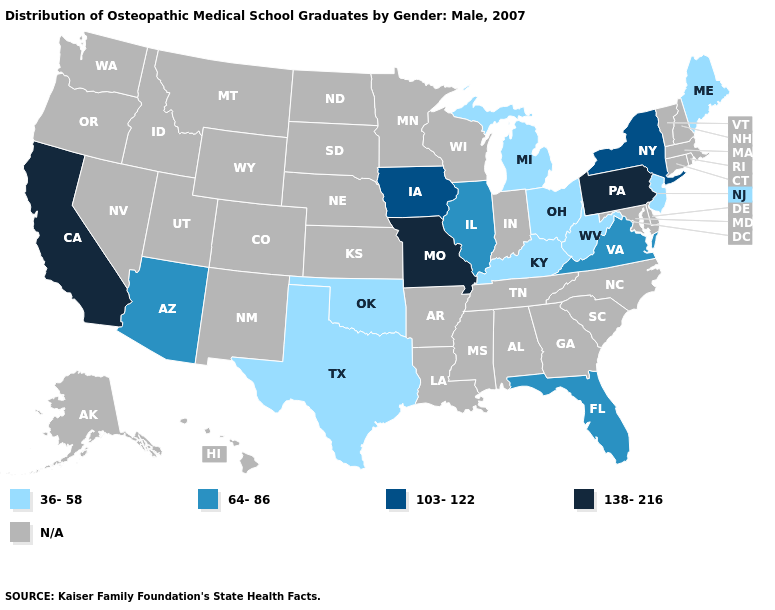Which states have the highest value in the USA?
Concise answer only. California, Missouri, Pennsylvania. Which states have the lowest value in the South?
Keep it brief. Kentucky, Oklahoma, Texas, West Virginia. Name the states that have a value in the range N/A?
Be succinct. Alabama, Alaska, Arkansas, Colorado, Connecticut, Delaware, Georgia, Hawaii, Idaho, Indiana, Kansas, Louisiana, Maryland, Massachusetts, Minnesota, Mississippi, Montana, Nebraska, Nevada, New Hampshire, New Mexico, North Carolina, North Dakota, Oregon, Rhode Island, South Carolina, South Dakota, Tennessee, Utah, Vermont, Washington, Wisconsin, Wyoming. Which states have the lowest value in the USA?
Concise answer only. Kentucky, Maine, Michigan, New Jersey, Ohio, Oklahoma, Texas, West Virginia. Among the states that border Texas , which have the highest value?
Concise answer only. Oklahoma. What is the value of New Jersey?
Quick response, please. 36-58. What is the value of Iowa?
Short answer required. 103-122. Does the map have missing data?
Give a very brief answer. Yes. Does Ohio have the lowest value in the USA?
Give a very brief answer. Yes. What is the value of Delaware?
Concise answer only. N/A. What is the value of West Virginia?
Keep it brief. 36-58. Does California have the lowest value in the West?
Short answer required. No. How many symbols are there in the legend?
Short answer required. 5. What is the highest value in the USA?
Answer briefly. 138-216. 